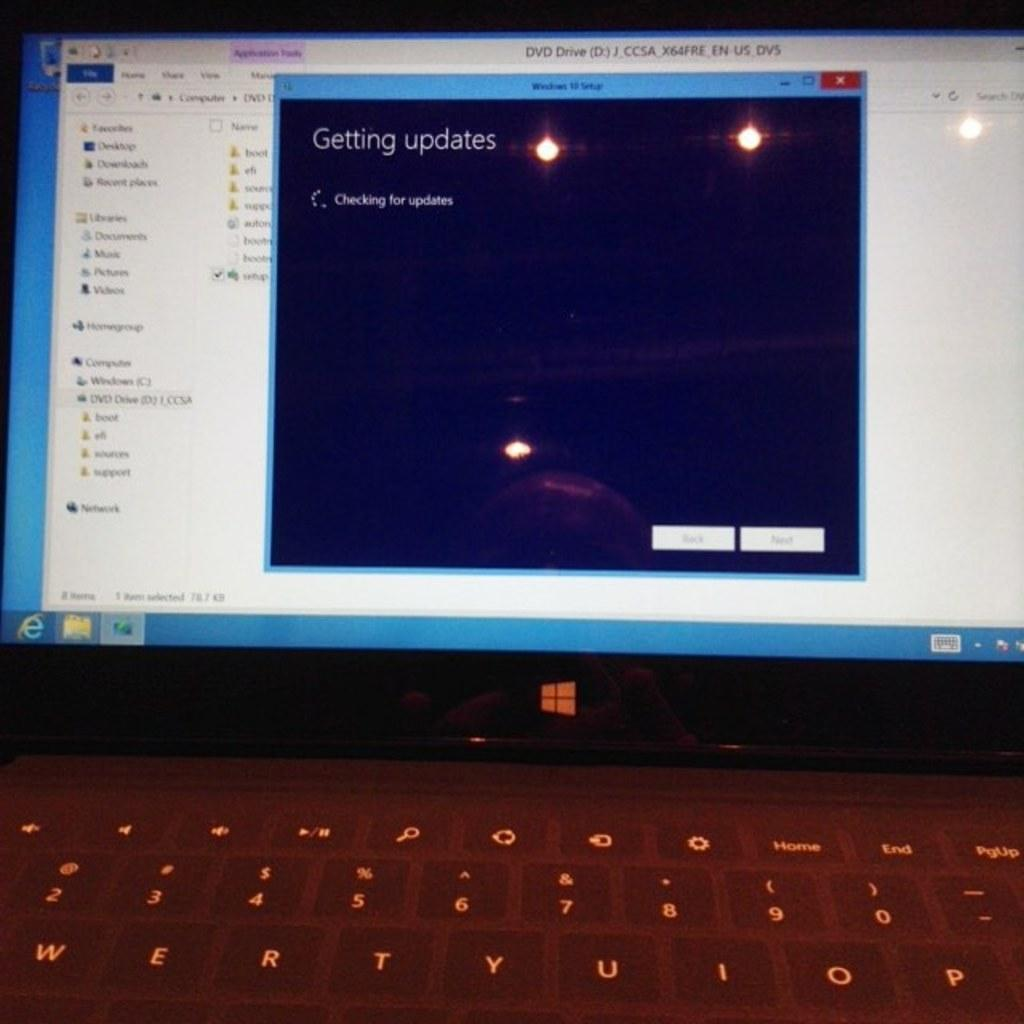<image>
Present a compact description of the photo's key features. Windows monitor showing that it is currently getting some updates. 